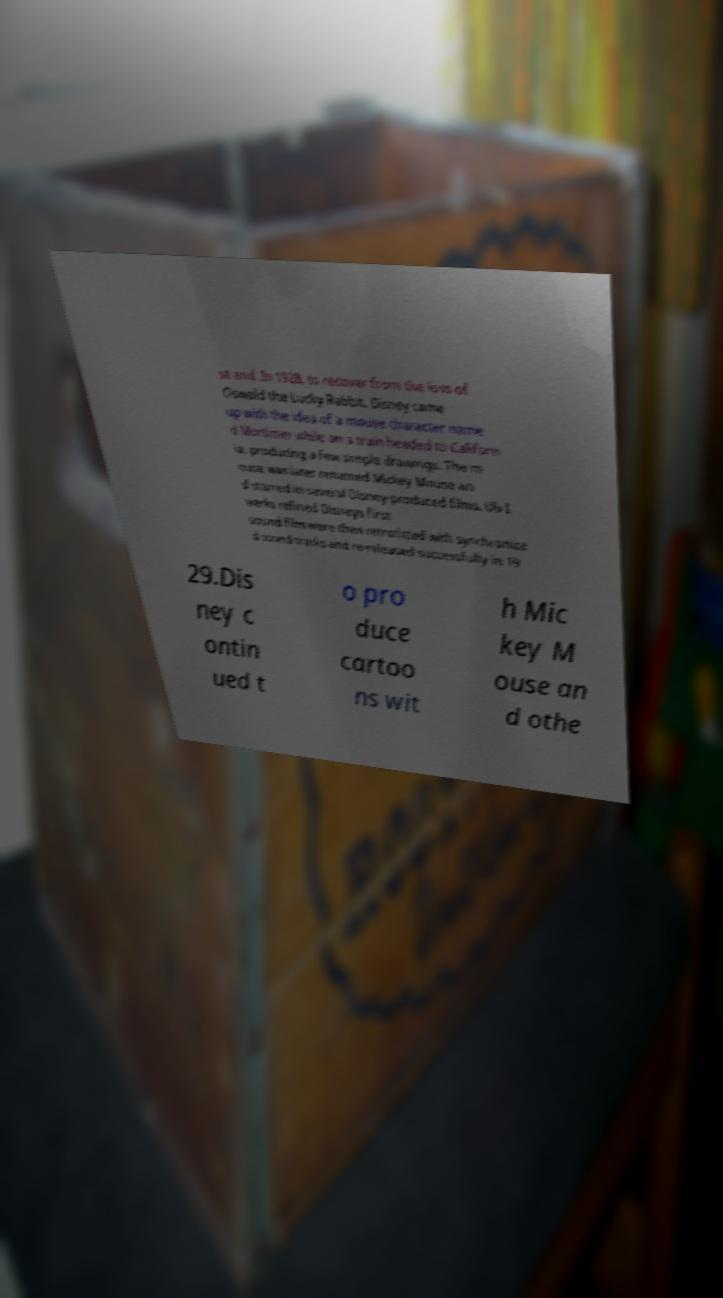There's text embedded in this image that I need extracted. Can you transcribe it verbatim? se and .In 1928, to recover from the loss of Oswald the Lucky Rabbit, Disney came up with the idea of a mouse character name d Mortimer while on a train headed to Californ ia, producing a few simple drawings. The m ouse was later renamed Mickey Mouse an d starred in several Disney-produced films. Ub I werks refined Disneys first sound film were then retrofitted with synchronize d sound tracks and re-released successfully in 19 29.Dis ney c ontin ued t o pro duce cartoo ns wit h Mic key M ouse an d othe 